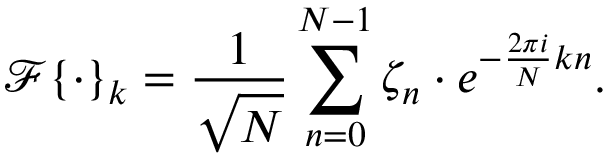Convert formula to latex. <formula><loc_0><loc_0><loc_500><loc_500>\mathcal { F } \{ \cdot \} _ { k } = \frac { 1 } { \sqrt { N } } \sum _ { n = 0 } ^ { N - 1 } \zeta _ { n } \cdot e ^ { - \frac { 2 \pi i } { N } k n } .</formula> 